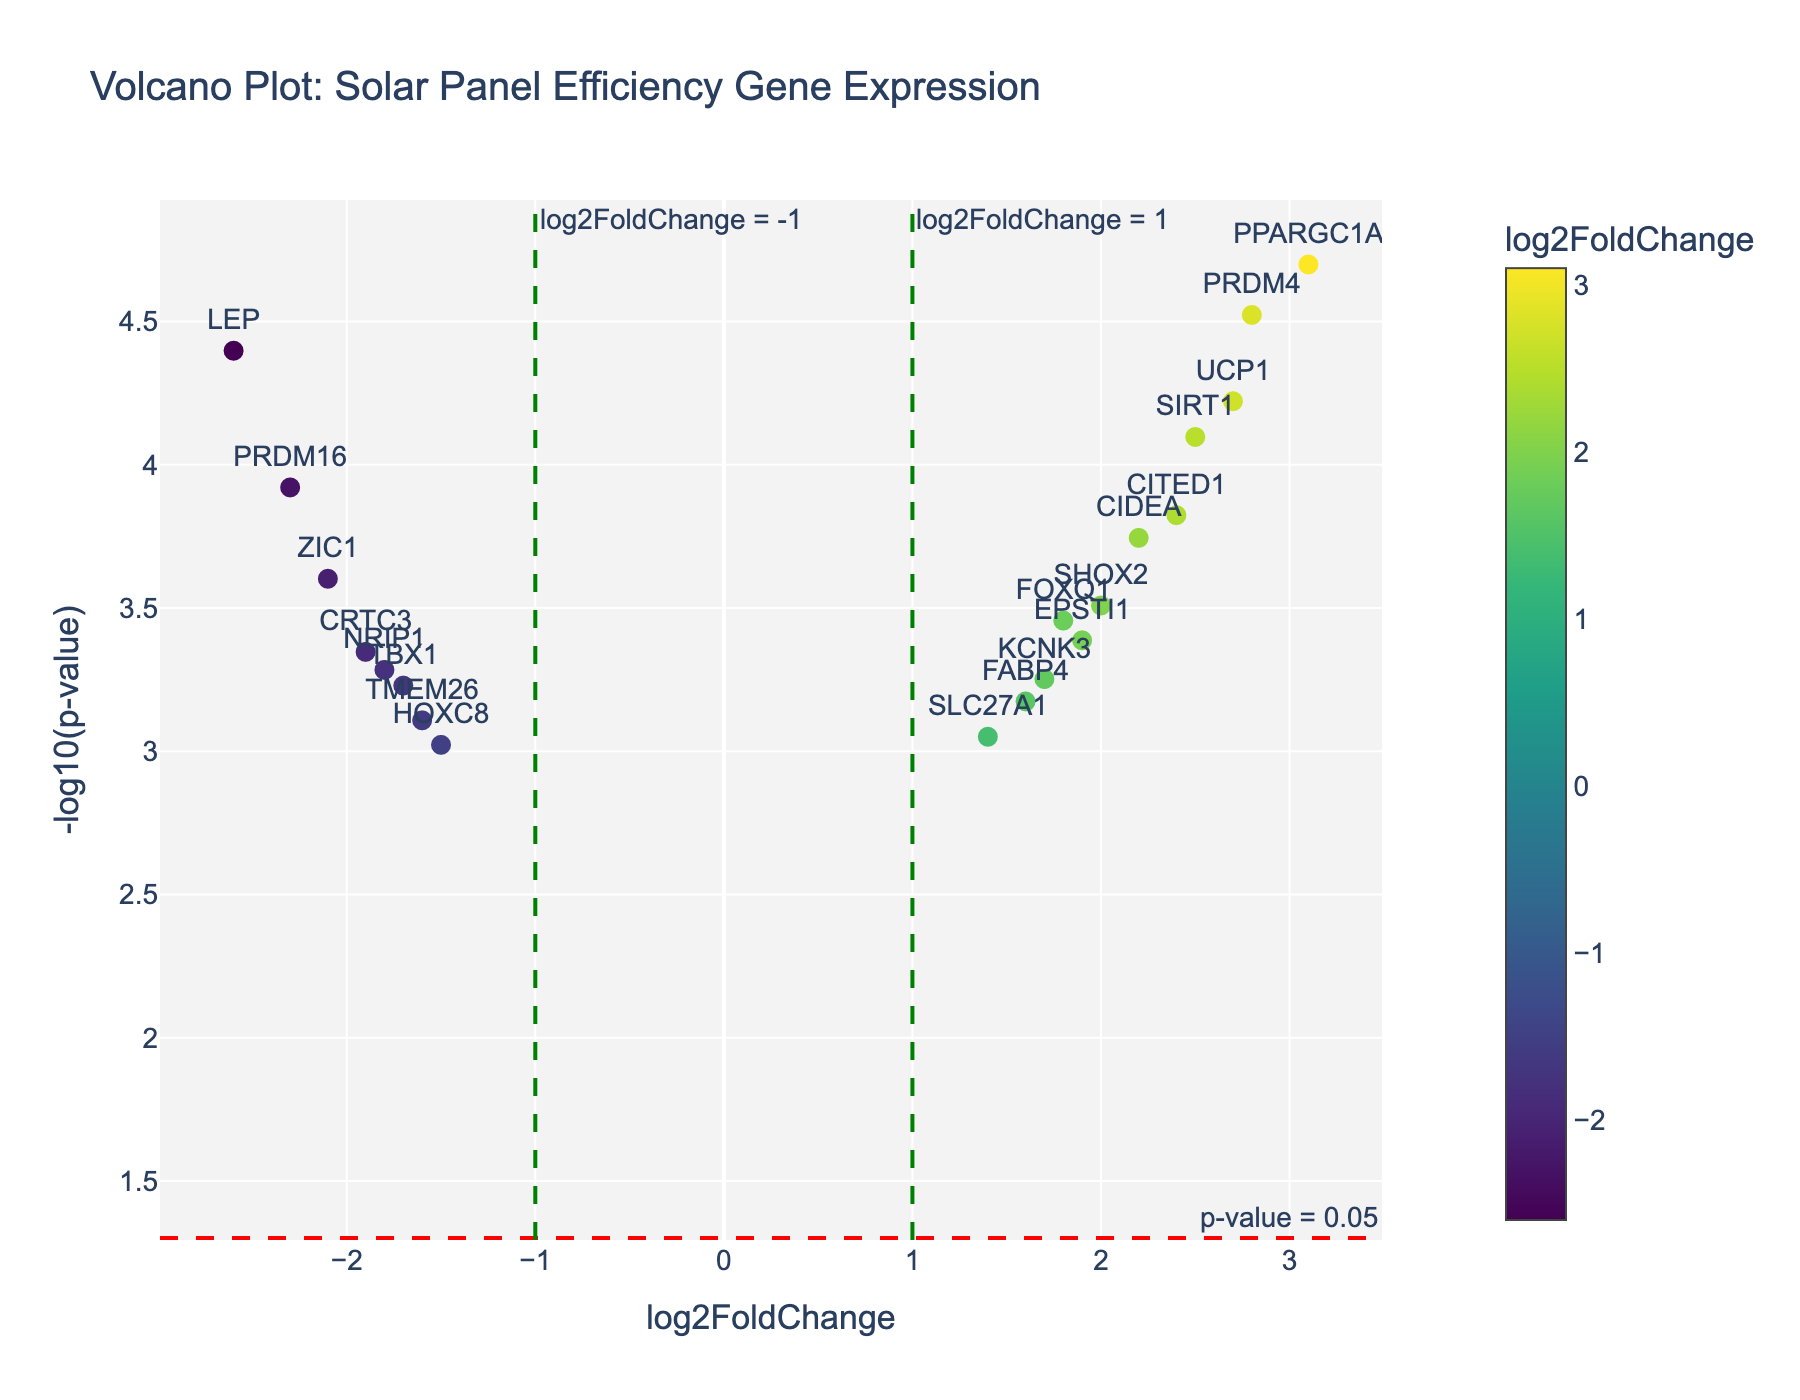What is the title of the plot? The title is typically located at the top of the plot, indicating its main topic. Here, it shows "Volcano Plot: Solar Panel Efficiency Gene Expression".
Answer: Volcano Plot: Solar Panel Efficiency Gene Expression What are the x-axis and y-axis labels? The axes are labeled to indicate what the scales represent. The x-axis is labeled "log2FoldChange", and the y-axis is labeled "-log10(p-value)".
Answer: log2FoldChange for x-axis, -log10(p-value) for y-axis How many genes have a log2FoldChange greater than 2? To find the answer, locate all the data points with log2FoldChange values greater than 2. The genes are SIRT1, PPARGC1A, UCP1, CIDEA, CITED1, PRDM4.
Answer: 6 Which gene has the highest log2FoldChange, and what is its value? Identify the gene farthest to the right on the x-axis. This is PPARGC1A with a log2FoldChange of 3.1.
Answer: PPARGC1A, 3.1 Which gene has the lowest p-value, and what is its value? The lowest p-value corresponds to the highest point on the y-axis. This is PPARGC1A, with a p-value of 0.00002.
Answer: PPARGC1A, 0.00002 How many genes have significant p-values (p < 0.05)? Count the data points that lie above the horizontal red dashed line, which corresponds to -log10(0.05). These genes are all being tested, adding up to 19.
Answer: 19 How many genes show both a significant log2FoldChange (greater than 1 or less than -1) and a p-value < 0.05? To find this, count the genes that lie outside the vertical green dashed lines (log2FoldChange > 1 or < -1) and above the horizontal red dashed line (p-value < 0.05). These genes include PRDM16, FOXQ1, SIRT1, PPARGC1A, CRTC3, UCP1, CIDEA, ZIC1, SHOX2, CITED1, LEP, PRDM4.
Answer: 12 Which gene shows the most significant downregulation, and what are its log2FoldChange and p-value? The most significant downregulation will have the most negative log2FoldChange and be highest on the y-axis. Here, PRDM16 has the most downregulation with log2FoldChange of -2.3 and a p-value of 0.00012.
Answer: PRDM16, log2FoldChange: -2.3, p-value: 0.00012 What is the range of the log2FoldChange values displayed on the plot? To find this, look at the minimum and maximum values on the x-axis. The lowest log2FoldChange is -2.6 (LEP) and the highest is 3.1 (PPARGC1A).
Answer: -2.6 to 3.1 